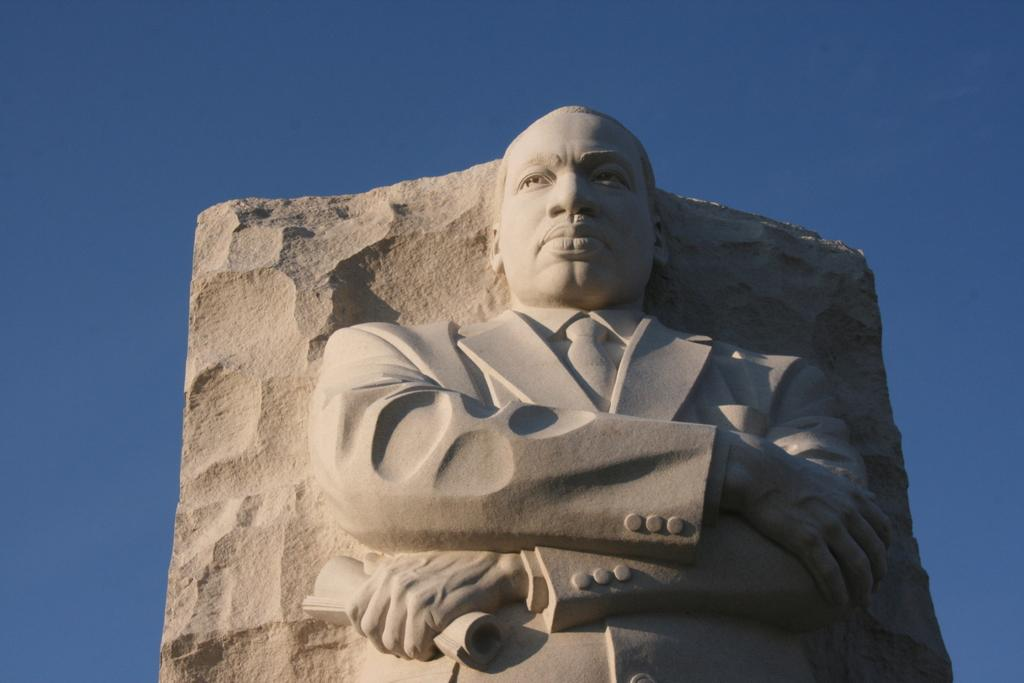What is the main subject in the center of the image? There is a statue in the center of the image. What can be seen in the background of the image? The sky is visible in the background of the image. How many geese are flying in the sky in the image? There are no geese present in the image; only the statue and sky are visible. 